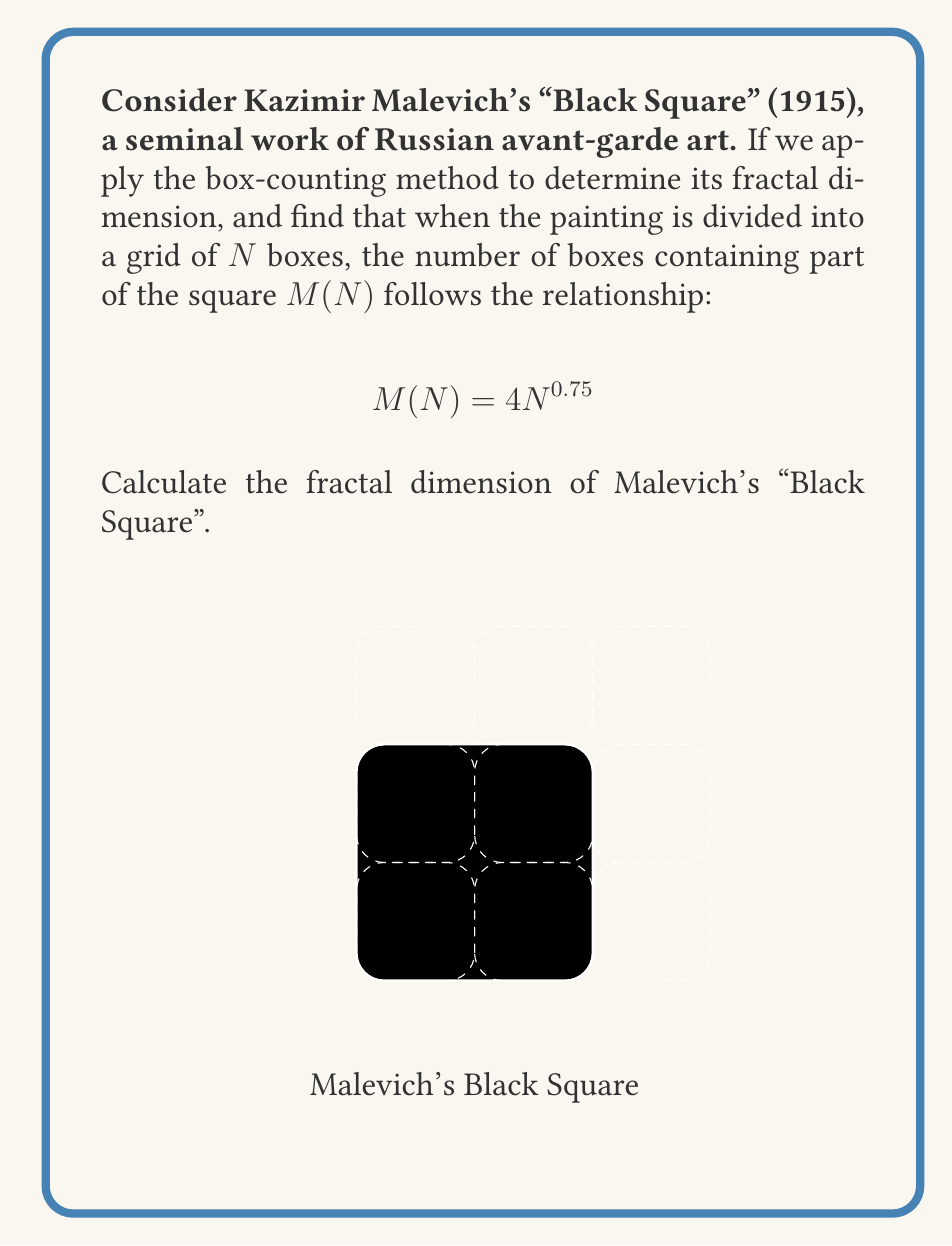Can you solve this math problem? To determine the fractal dimension of Malevich's "Black Square" using the box-counting method, we need to apply the following steps:

1) The general formula for the box-counting dimension is:

   $$D = \lim_{N \to \infty} \frac{\log M(N)}{\log N}$$

   where $D$ is the fractal dimension, $N$ is the number of boxes, and $M(N)$ is the number of boxes containing part of the fractal.

2) We are given that $M(N) = 4N^{0.75}$. Let's substitute this into our formula:

   $$D = \lim_{N \to \infty} \frac{\log (4N^{0.75})}{\log N}$$

3) Using the logarithm properties, we can simplify:

   $$D = \lim_{N \to \infty} \frac{\log 4 + 0.75 \log N}{\log N}$$

4) As $N$ approaches infinity, $\log 4$ becomes negligible compared to $0.75 \log N$:

   $$D = \lim_{N \to \infty} \frac{0.75 \log N}{\log N}$$

5) The $\log N$ terms cancel out:

   $$D = \lim_{N \to \infty} 0.75 = 0.75$$

Therefore, the fractal dimension of Malevich's "Black Square" is 0.75.
Answer: $0.75$ 